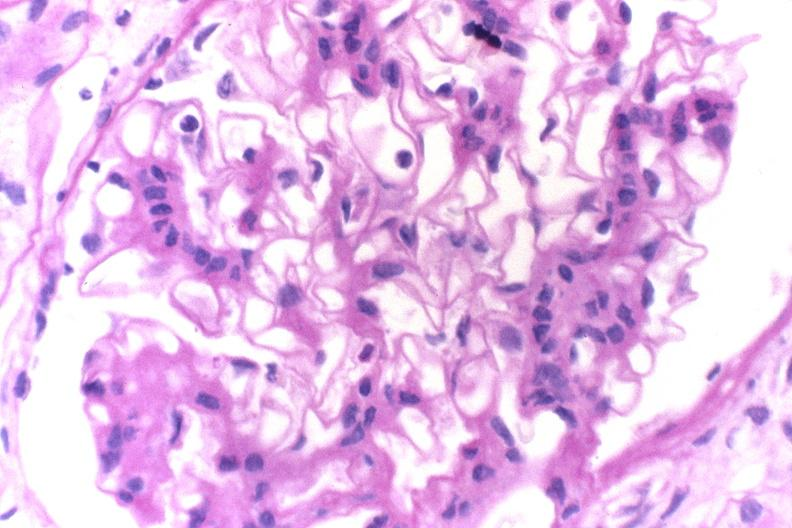what is present?
Answer the question using a single word or phrase. Urinary 